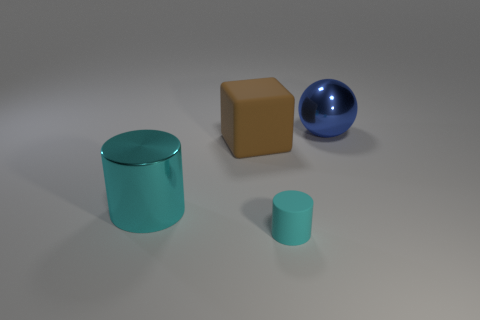Add 4 gray shiny cylinders. How many objects exist? 8 Subtract all balls. How many objects are left? 3 Add 3 large cylinders. How many large cylinders exist? 4 Subtract 0 green spheres. How many objects are left? 4 Subtract all yellow spheres. Subtract all purple cylinders. How many spheres are left? 1 Subtract all cylinders. Subtract all large brown rubber cylinders. How many objects are left? 2 Add 1 brown things. How many brown things are left? 2 